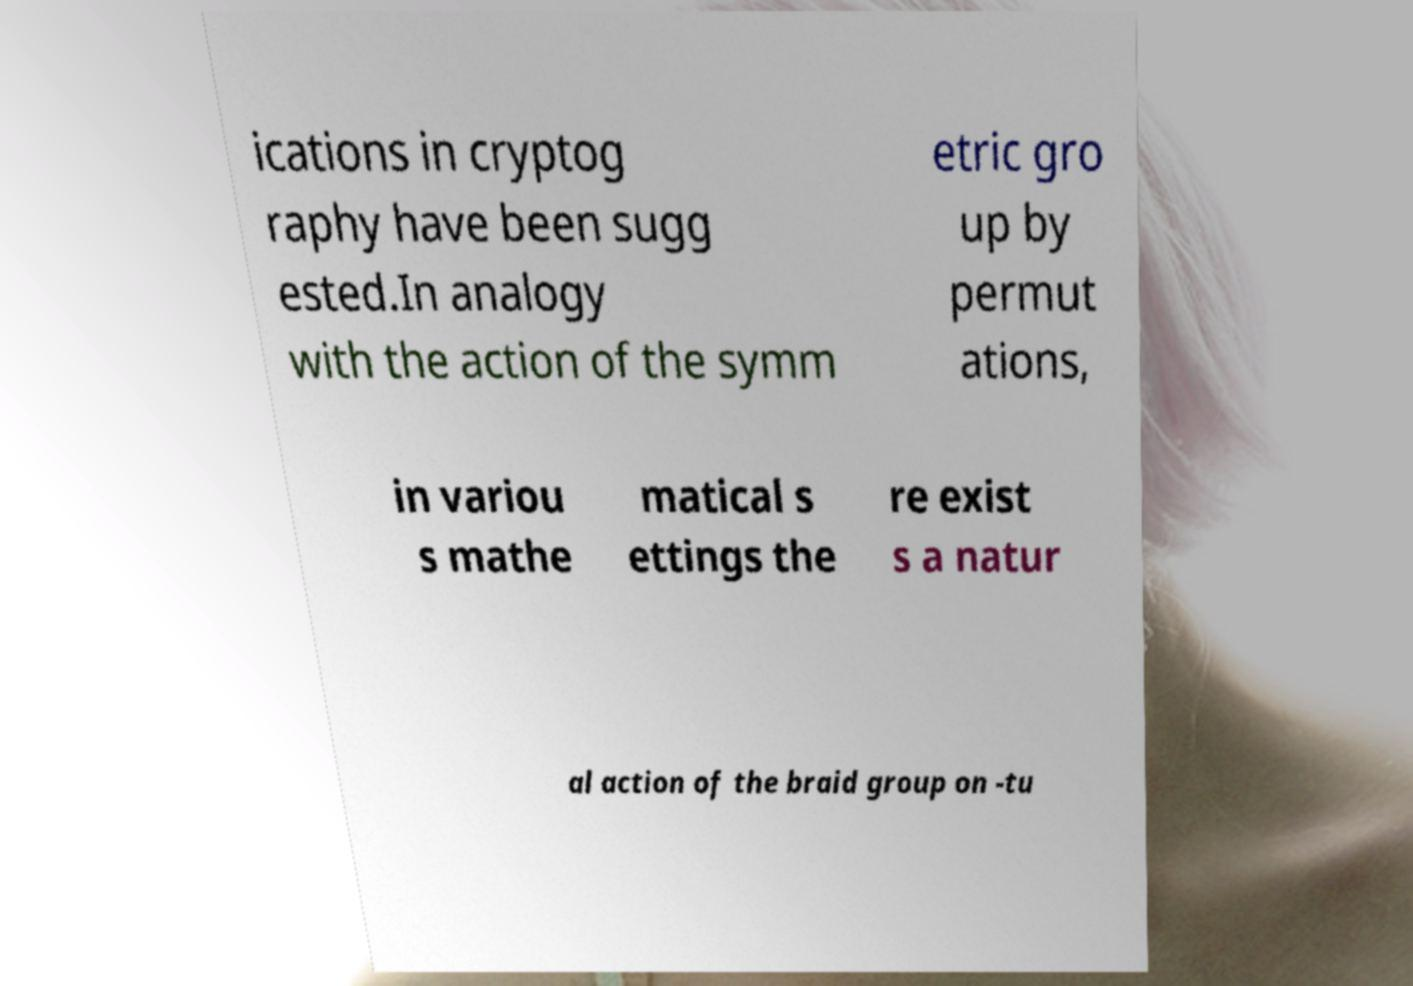Can you accurately transcribe the text from the provided image for me? ications in cryptog raphy have been sugg ested.In analogy with the action of the symm etric gro up by permut ations, in variou s mathe matical s ettings the re exist s a natur al action of the braid group on -tu 